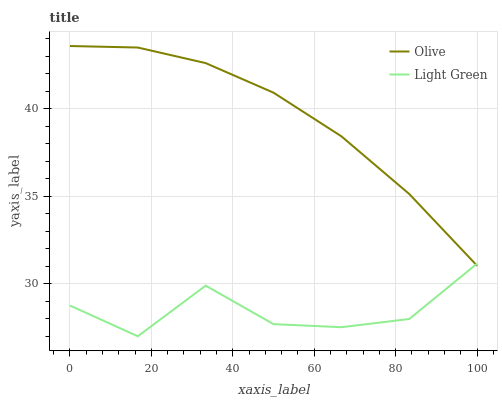Does Light Green have the maximum area under the curve?
Answer yes or no. No. Is Light Green the smoothest?
Answer yes or no. No. Does Light Green have the highest value?
Answer yes or no. No. 